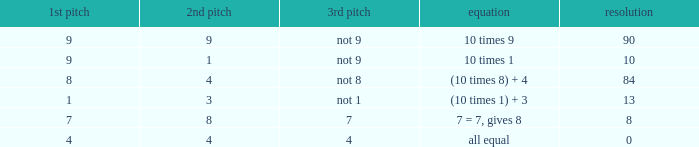If the equation is (10 times 8) + 4, what would be the 2nd throw? 4.0. 